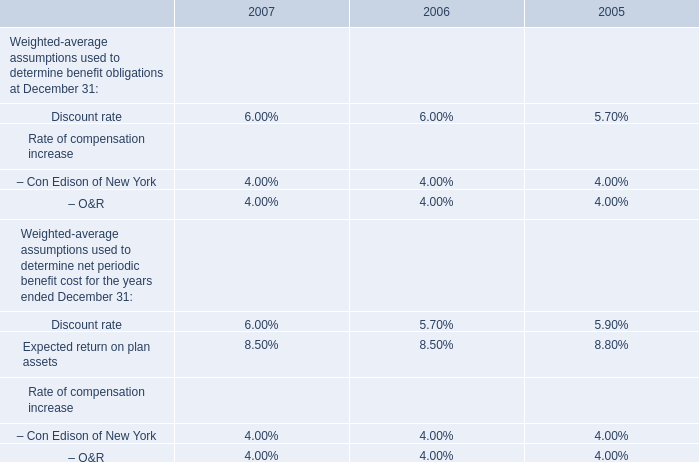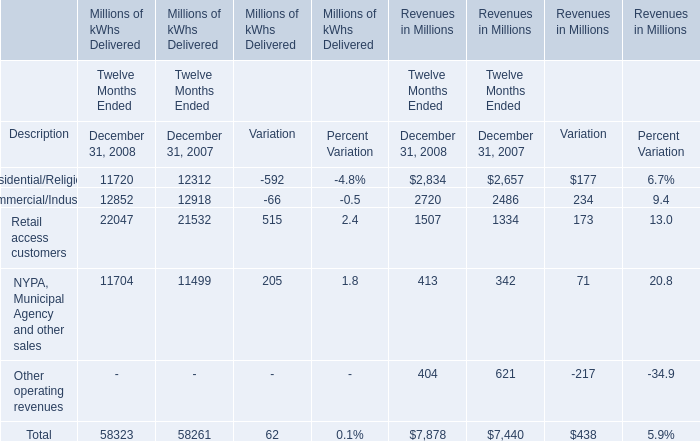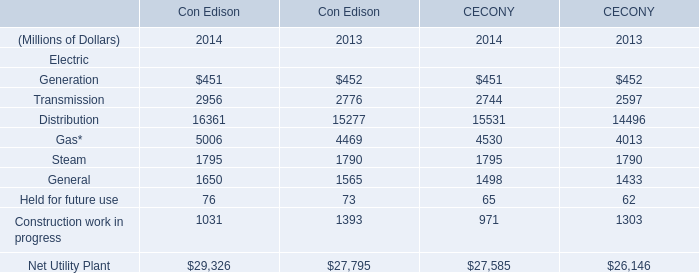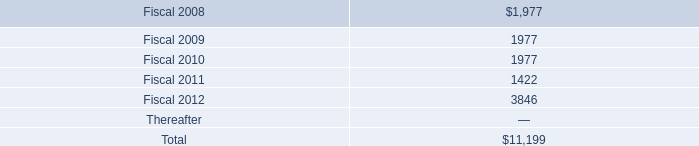Which year has the greatest proportion of Retail access customers in delivered? 
Computations: ((22047 / 58323) - (21532 / 58261))
Answer: 0.00844. 